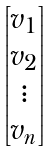Convert formula to latex. <formula><loc_0><loc_0><loc_500><loc_500>\begin{bmatrix} v _ { 1 } \\ v _ { 2 } \\ \vdots \\ v _ { n } \end{bmatrix}</formula> 